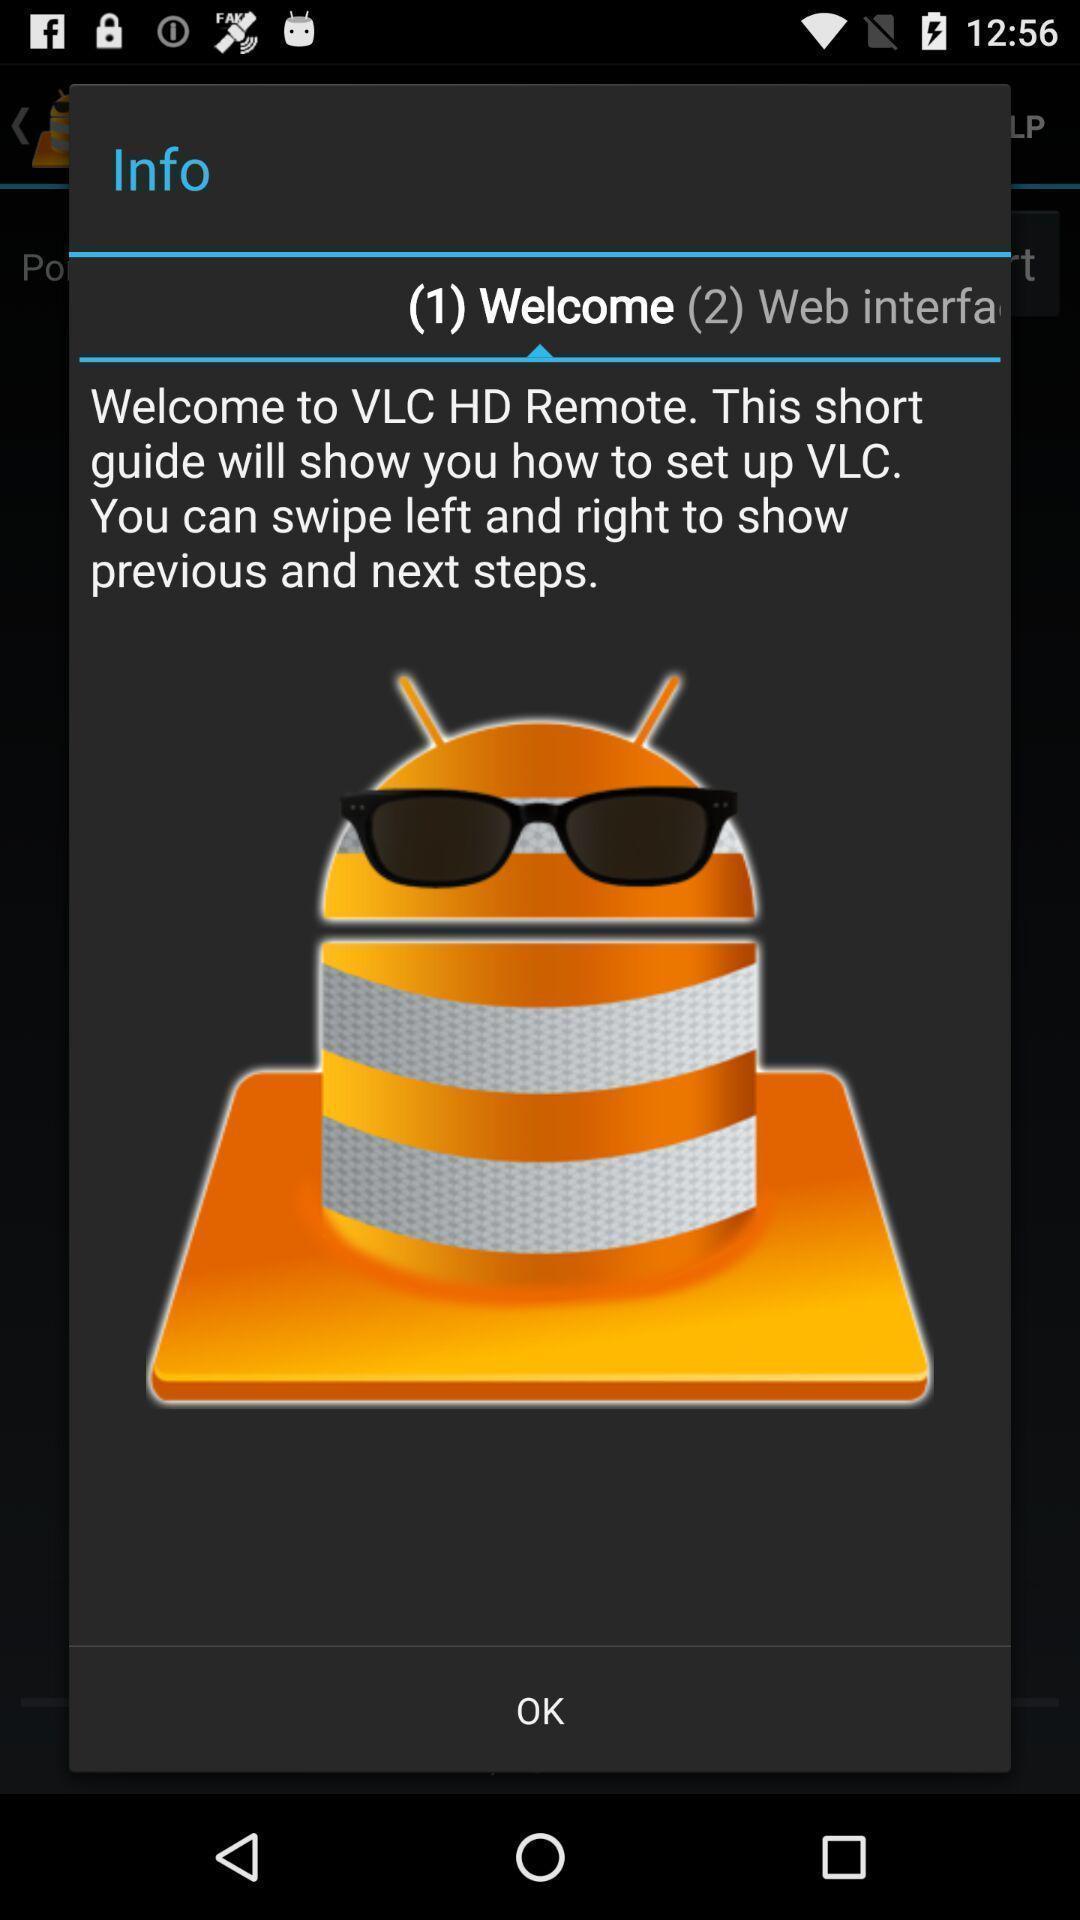Tell me what you see in this picture. Pop up showing of a video player app. 